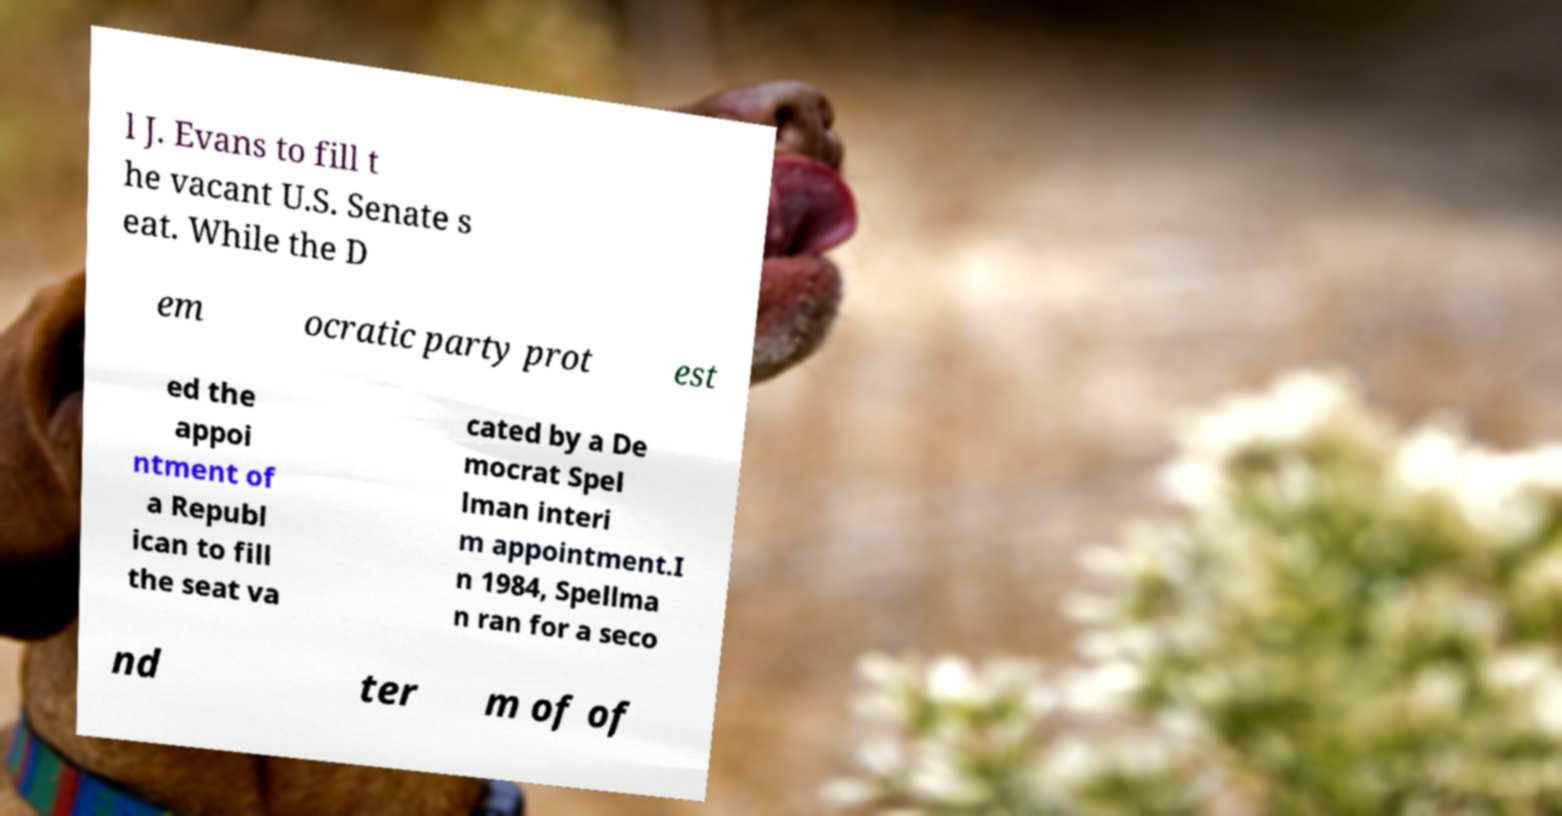Could you assist in decoding the text presented in this image and type it out clearly? l J. Evans to fill t he vacant U.S. Senate s eat. While the D em ocratic party prot est ed the appoi ntment of a Republ ican to fill the seat va cated by a De mocrat Spel lman interi m appointment.I n 1984, Spellma n ran for a seco nd ter m of of 